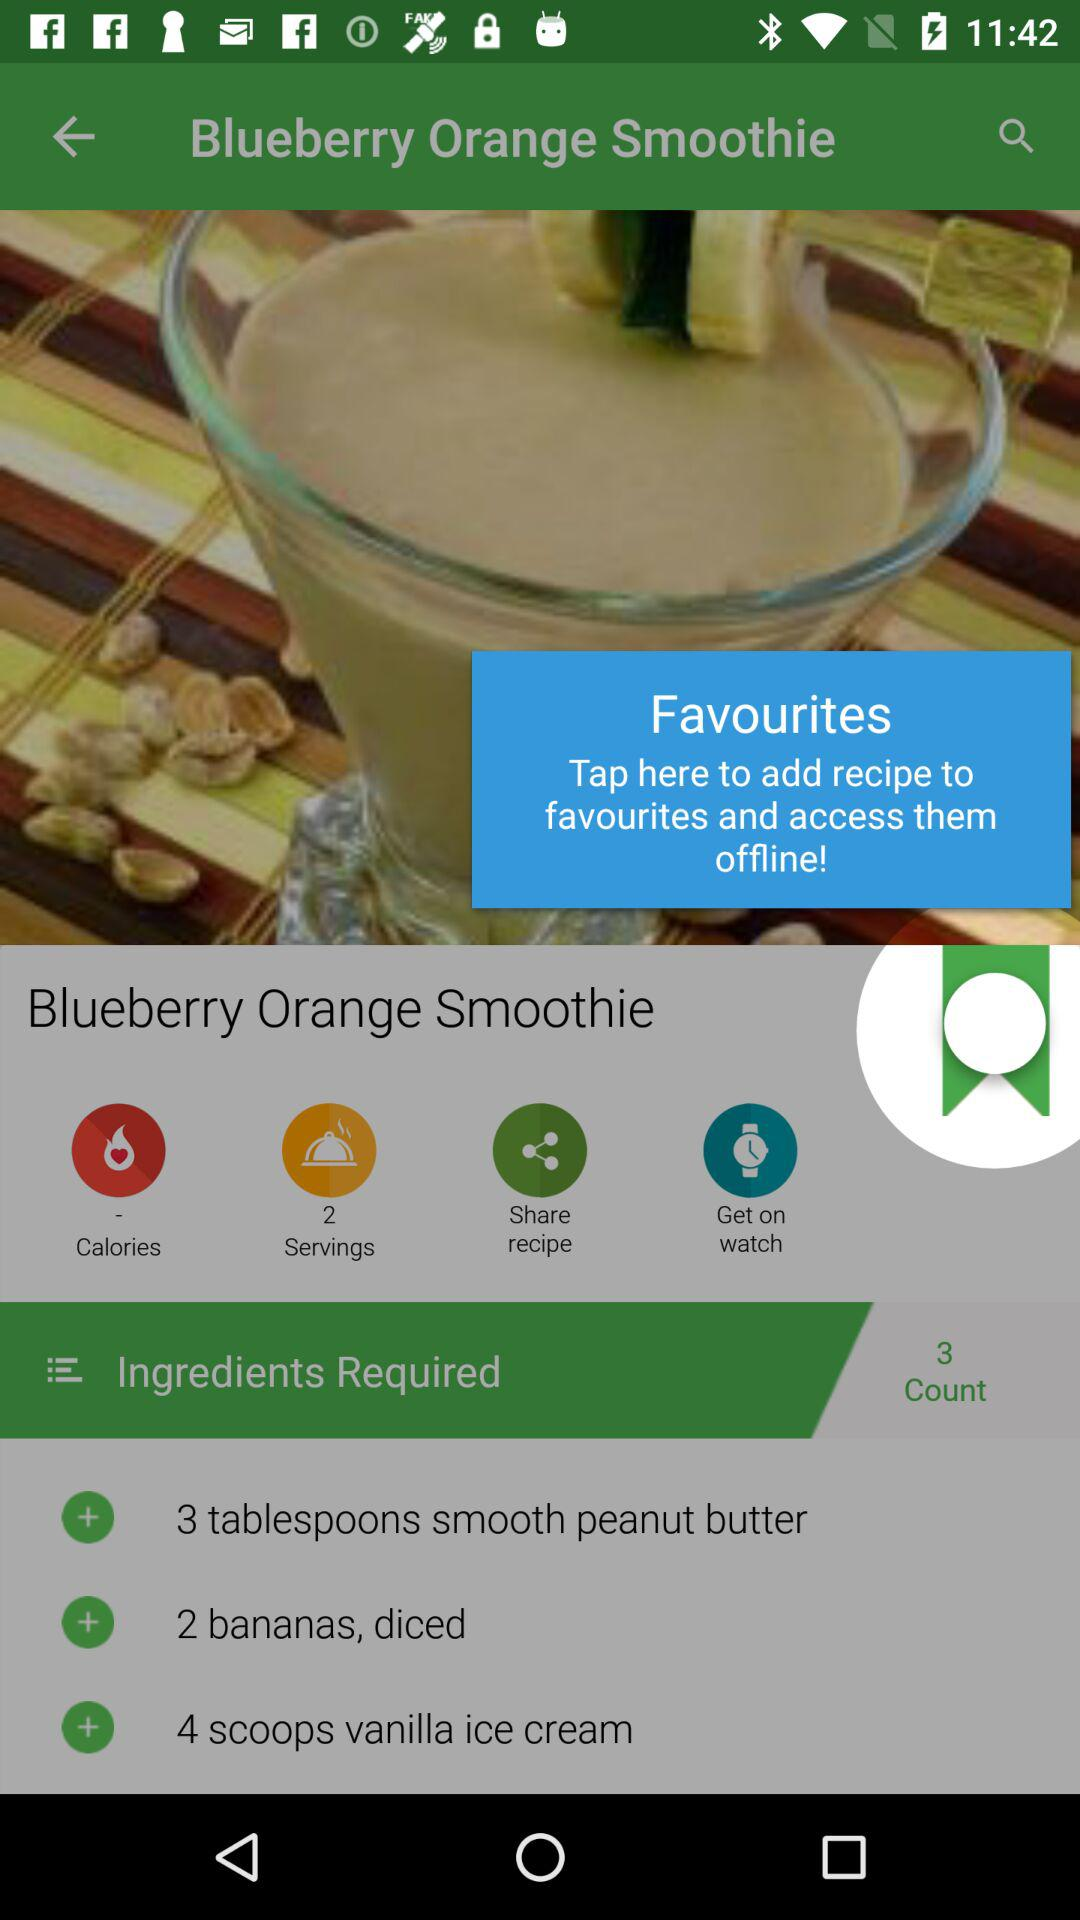How many people can the dish be served to? The dish can be served to 2 people. 